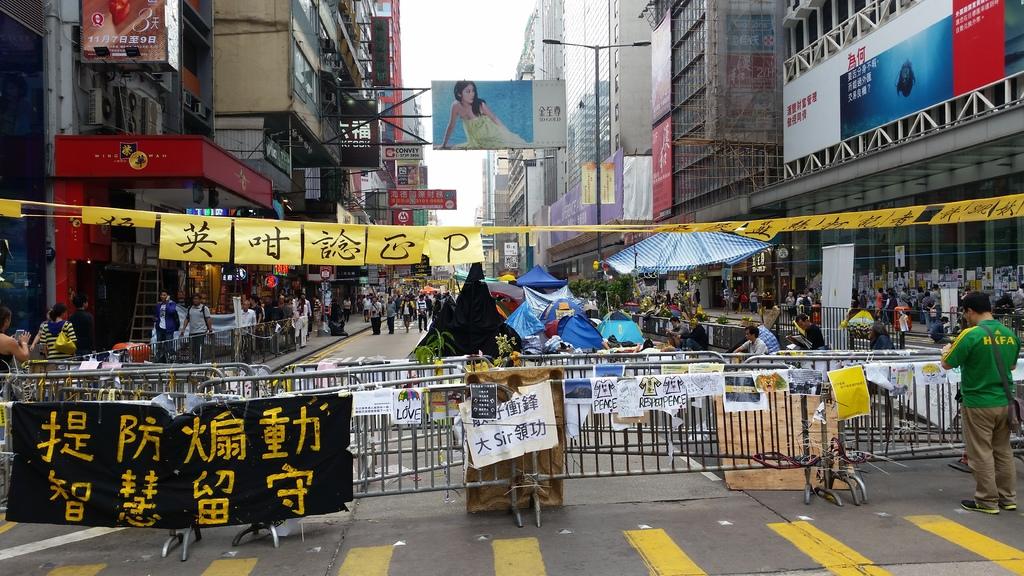What is the only english letter on the yellow banners?
Provide a short and direct response. P. What is written on the green shirt on the right?
Your answer should be very brief. Hkfa. 